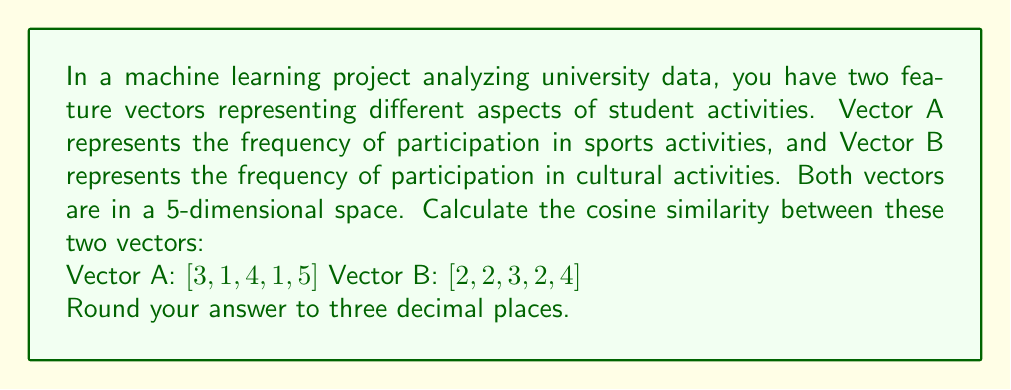Give your solution to this math problem. To calculate the cosine similarity between two vectors in a high-dimensional space, we use the following formula:

$$\text{cosine similarity} = \frac{\mathbf{A} \cdot \mathbf{B}}{\|\mathbf{A}\| \|\mathbf{B}\|}$$

Where $\mathbf{A} \cdot \mathbf{B}$ is the dot product of the vectors, and $\|\mathbf{A}\|$ and $\|\mathbf{B}\|$ are the magnitudes (Euclidean norms) of vectors A and B respectively.

Step 1: Calculate the dot product $\mathbf{A} \cdot \mathbf{B}$
$$\mathbf{A} \cdot \mathbf{B} = (3 \times 2) + (1 \times 2) + (4 \times 3) + (1 \times 2) + (5 \times 4) = 6 + 2 + 12 + 2 + 20 = 42$$

Step 2: Calculate the magnitude of vector A
$$\|\mathbf{A}\| = \sqrt{3^2 + 1^2 + 4^2 + 1^2 + 5^2} = \sqrt{9 + 1 + 16 + 1 + 25} = \sqrt{52} \approx 7.211$$

Step 3: Calculate the magnitude of vector B
$$\|\mathbf{B}\| = \sqrt{2^2 + 2^2 + 3^2 + 2^2 + 4^2} = \sqrt{4 + 4 + 9 + 4 + 16} = \sqrt{37} \approx 6.083$$

Step 4: Apply the cosine similarity formula
$$\text{cosine similarity} = \frac{42}{7.211 \times 6.083} \approx 0.957$$

Step 5: Round to three decimal places
$$\text{cosine similarity} \approx 0.957$$
Answer: 0.957 